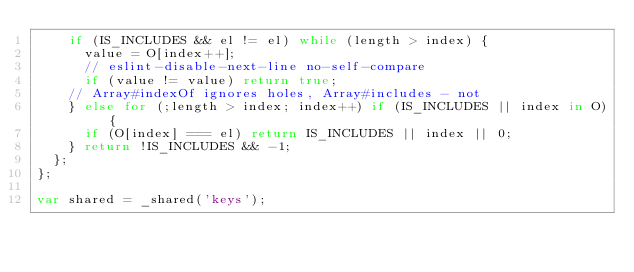Convert code to text. <code><loc_0><loc_0><loc_500><loc_500><_JavaScript_>    if (IS_INCLUDES && el != el) while (length > index) {
      value = O[index++];
      // eslint-disable-next-line no-self-compare
      if (value != value) return true;
    // Array#indexOf ignores holes, Array#includes - not
    } else for (;length > index; index++) if (IS_INCLUDES || index in O) {
      if (O[index] === el) return IS_INCLUDES || index || 0;
    } return !IS_INCLUDES && -1;
  };
};

var shared = _shared('keys');
</code> 